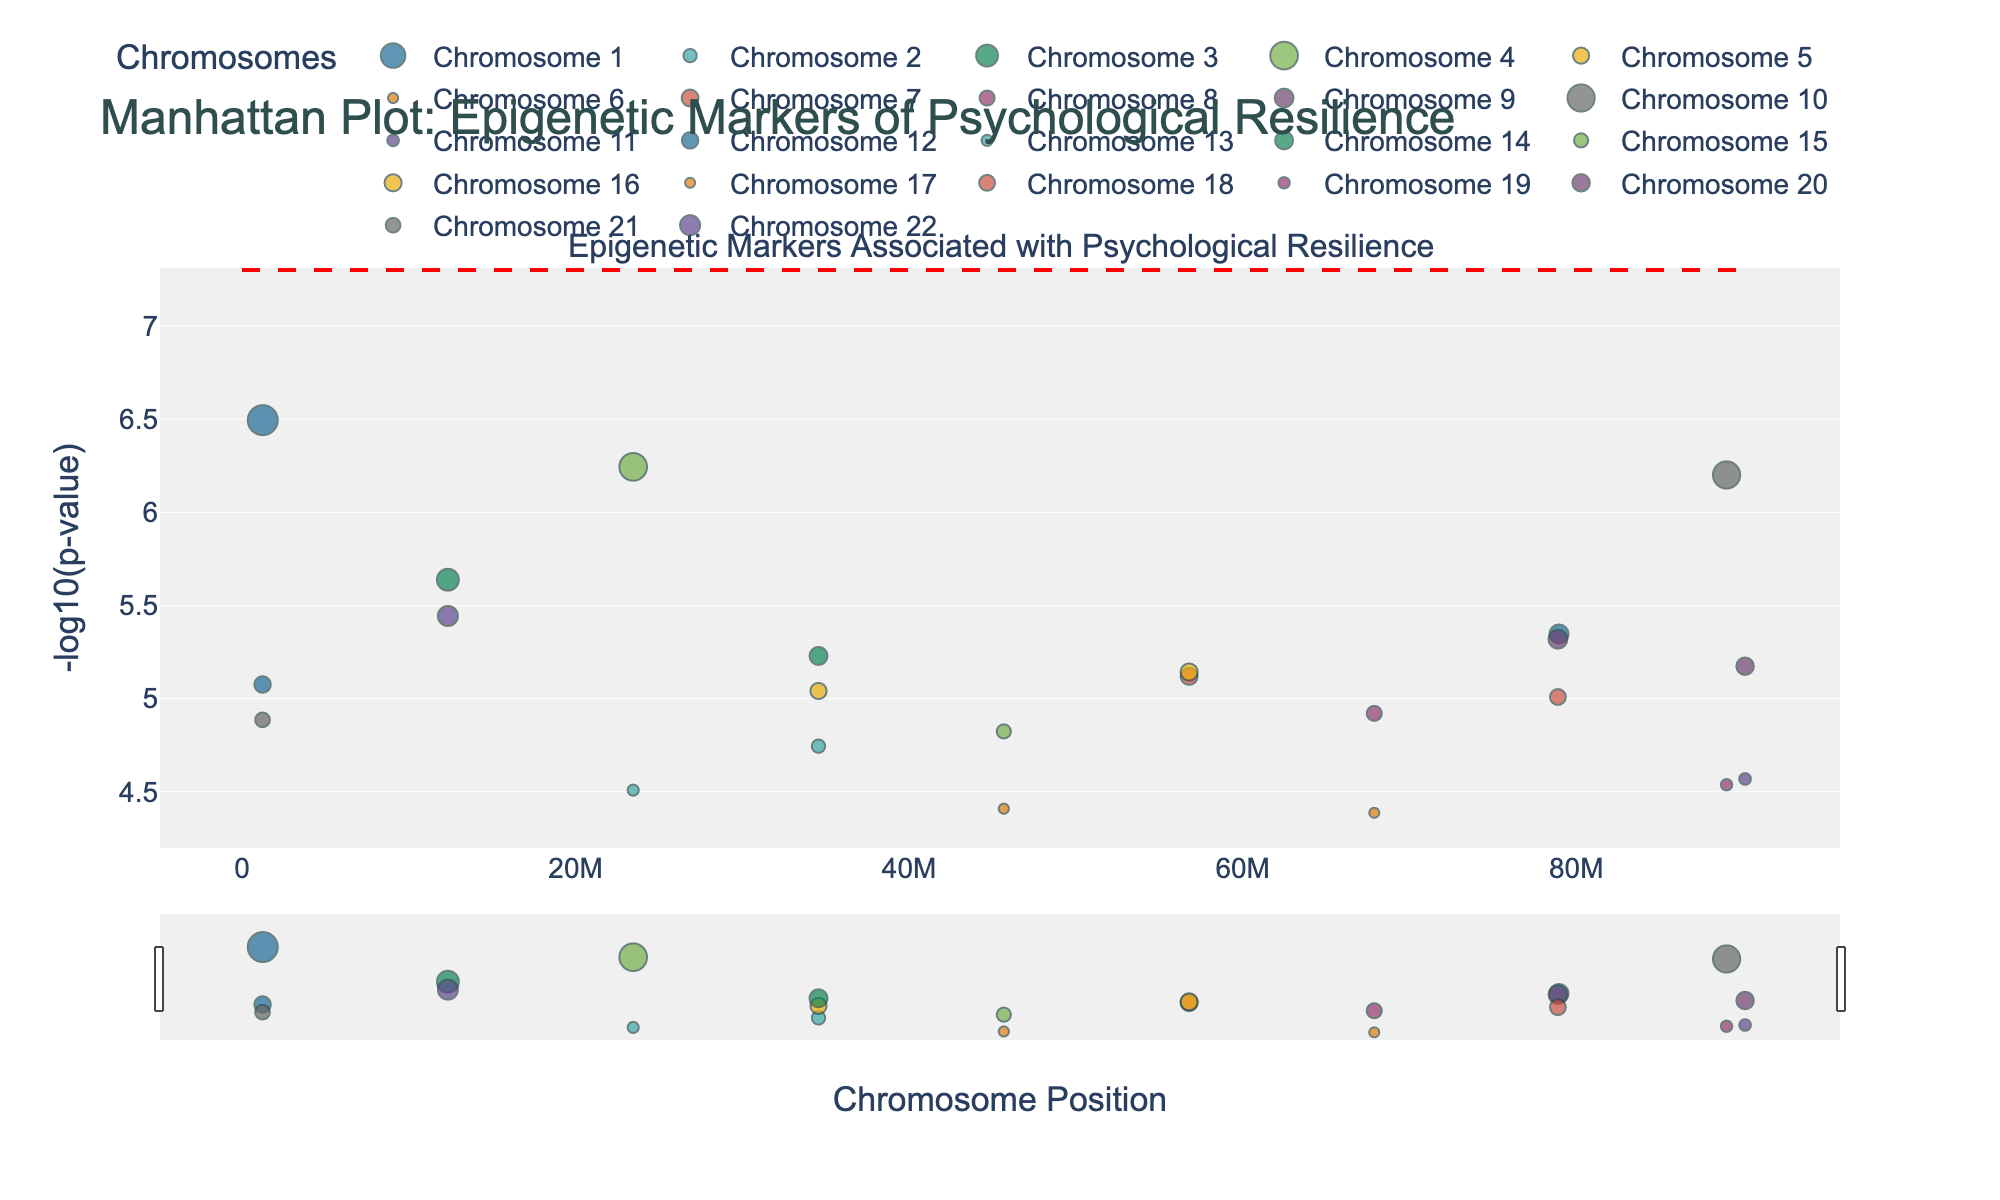What's the title of the plot? The title of the plot is placed at the top of the figure. It is the first text you encounter, making the main topic of the plot easily identifiable.
Answer: Manhattan Plot: Epigenetic Markers of Psychological Resilience Which chromosome has the most significant p-value? To determine this, identify the data point with the highest -log10(p-value), as it corresponds to the most significant p-value. Look for its corresponding chromosome in the plot's legend or data hover.
Answer: Chromosome 1 (OXTR gene) What is the -log10(p-value) of the SLC6A4 gene on Chromosome 4? Hover over the data points or check the figure legend to identify the position of the SLC6A4 gene on Chromosome 4, then note the y-axis value.
Answer: Approximately 6.24 Which gene on Chromosome 9 has a significant p-value? By identifying the location of Chromosome 9 in the figure and hovering over its data points, you can see the gene names.
Answer: NPY gene How many data points have a -log10(p-value) greater than 7? To answer this, count the number of data points that appear above the 7 mark on the y-axis.
Answer: Two data points Which chromosome has the highest number of significant markers below the red significance line? Examine the data points under the red line indicating significance on the plot. Count those related to each chromosome and identify the highest count.
Answer: Chromosome 1 Is the FKBP5 gene represented in more than one chromosome? By examining the figure's hover data or legend, check if FKBP5 appears in multiple chromosomal locations.
Answer: Yes, Chromosomes 5 and 20 What is the position of the OXTR gene on Chromosome 1? Using the hover function or note from the data table, find the position next to OXTR on Chromosome 1.
Answer: Position 1245678 Which gene is located at the highest y-axis value among those associated with psychological resilience? Identify the gene associated with the highest -log10(p-value) by examining the peak y-axis values on the plot.
Answer: OXTR gene What is the general trend of p-values across different chromosomes? By visually examining the scatter plots across chromosomes, note the distribution and any patterns of -log10(p-values).
Answer: p-values vary widely across chromosomes, with certain hotspots of higher significance 